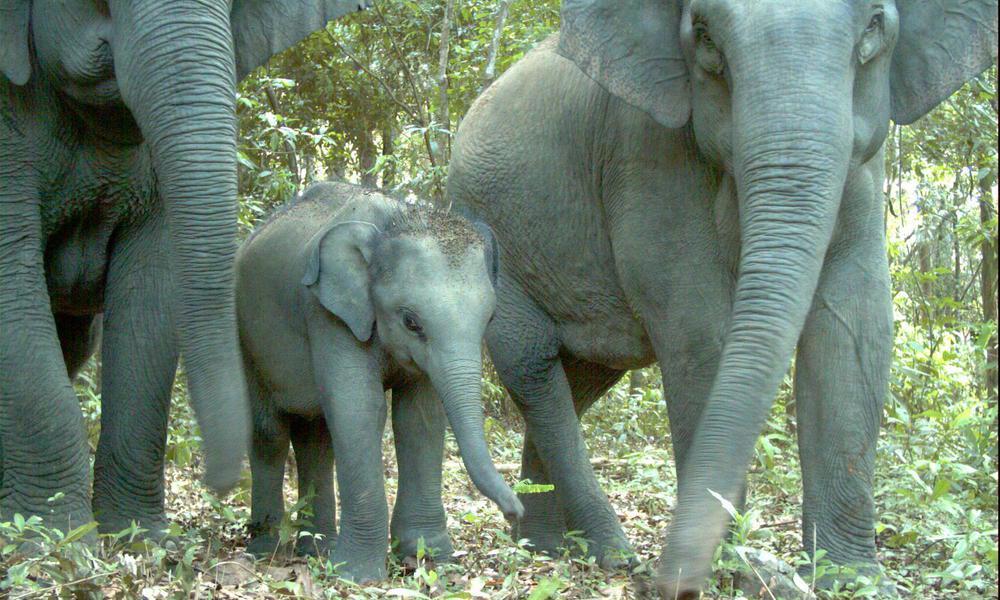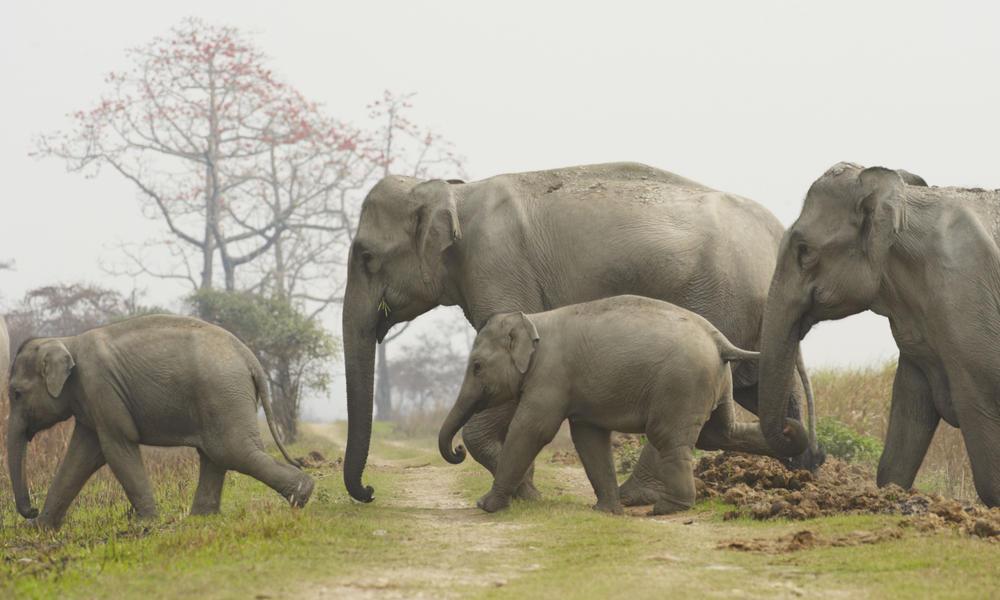The first image is the image on the left, the second image is the image on the right. Examine the images to the left and right. Is the description "Three elephants walk together in the image on the left." accurate? Answer yes or no. Yes. The first image is the image on the left, the second image is the image on the right. Examine the images to the left and right. Is the description "One image includes leftward-facing adult and young elephants." accurate? Answer yes or no. Yes. 